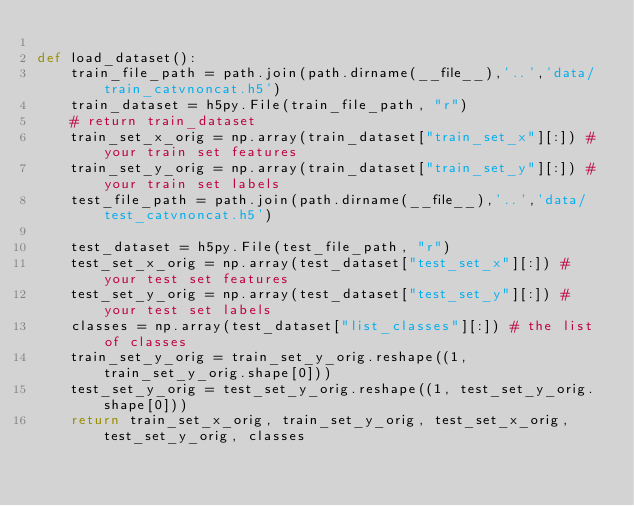<code> <loc_0><loc_0><loc_500><loc_500><_Python_>    
def load_dataset():
    train_file_path = path.join(path.dirname(__file__),'..','data/train_catvnoncat.h5')
    train_dataset = h5py.File(train_file_path, "r")
    # return train_dataset
    train_set_x_orig = np.array(train_dataset["train_set_x"][:]) # your train set features
    train_set_y_orig = np.array(train_dataset["train_set_y"][:]) # your train set labels
    test_file_path = path.join(path.dirname(__file__),'..','data/test_catvnoncat.h5')
    
    test_dataset = h5py.File(test_file_path, "r")
    test_set_x_orig = np.array(test_dataset["test_set_x"][:]) # your test set features
    test_set_y_orig = np.array(test_dataset["test_set_y"][:]) # your test set labels
    classes = np.array(test_dataset["list_classes"][:]) # the list of classes    
    train_set_y_orig = train_set_y_orig.reshape((1, train_set_y_orig.shape[0]))
    test_set_y_orig = test_set_y_orig.reshape((1, test_set_y_orig.shape[0]))    
    return train_set_x_orig, train_set_y_orig, test_set_x_orig, test_set_y_orig, classes</code> 